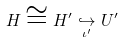Convert formula to latex. <formula><loc_0><loc_0><loc_500><loc_500>H \cong H ^ { \prime } \underset { { \iota } ^ { \prime } } { \hookrightarrow } { U } ^ { \prime }</formula> 